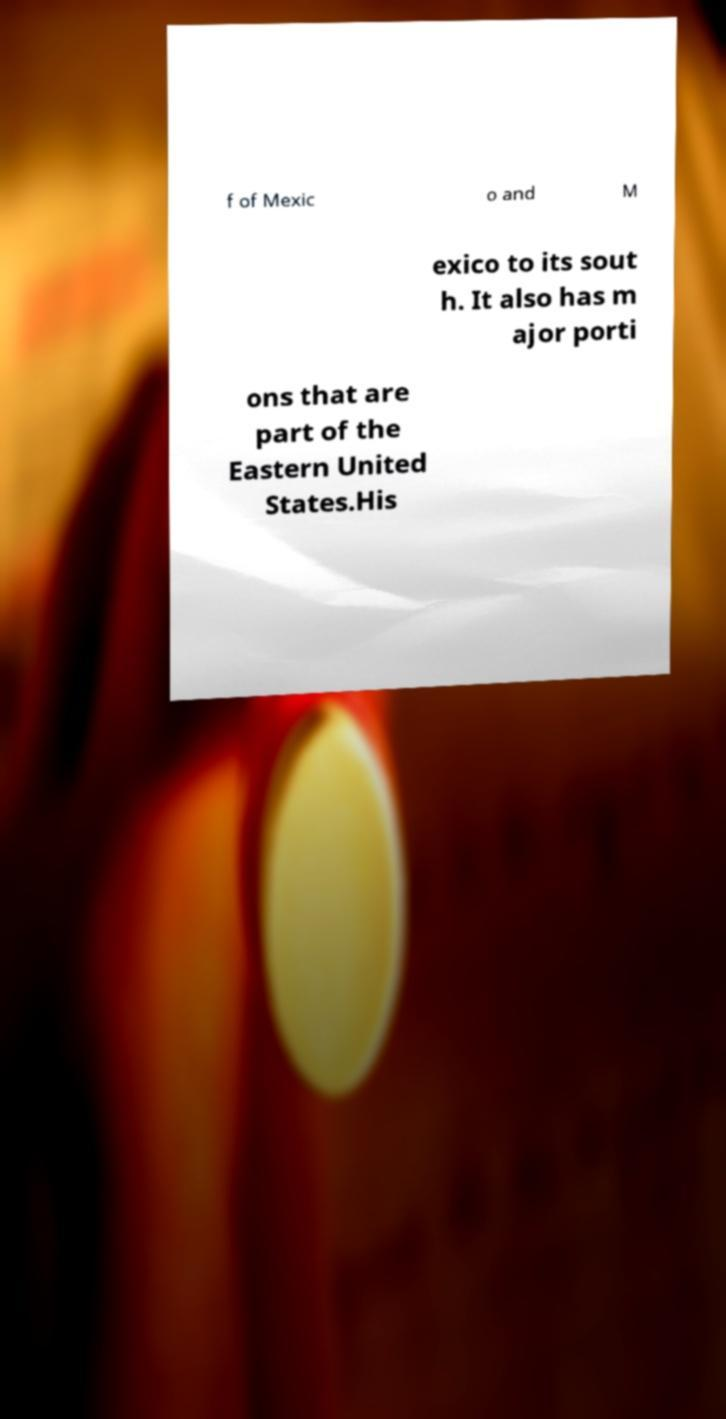What messages or text are displayed in this image? I need them in a readable, typed format. f of Mexic o and M exico to its sout h. It also has m ajor porti ons that are part of the Eastern United States.His 